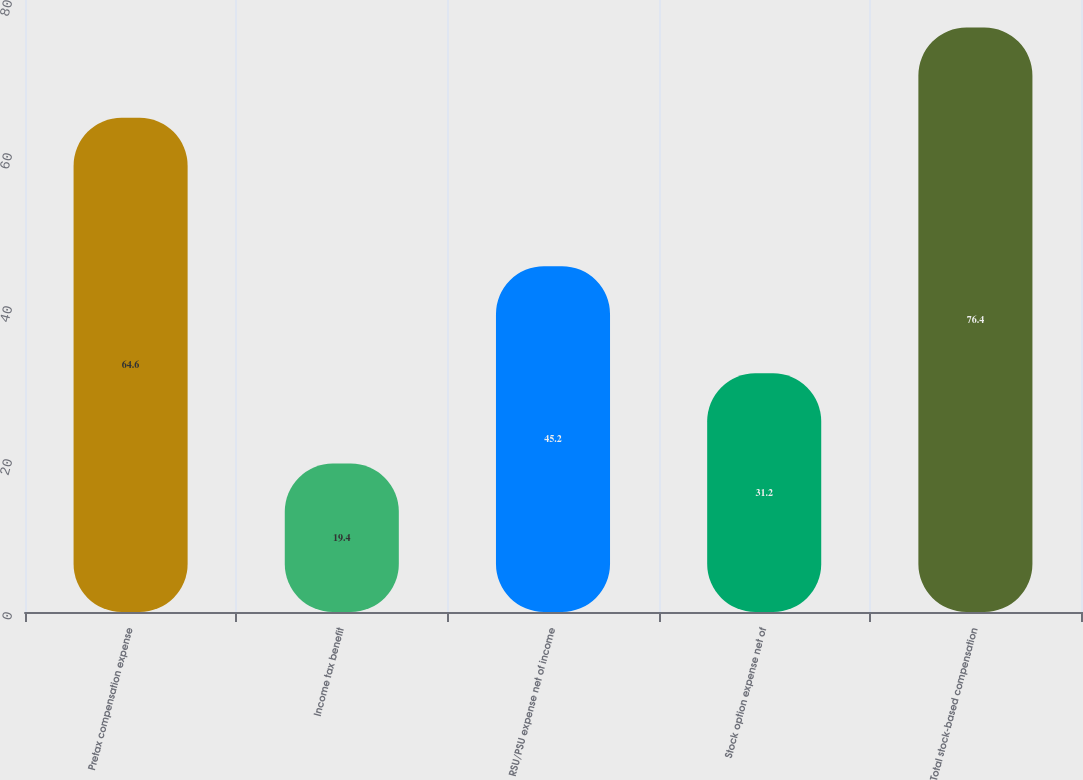Convert chart. <chart><loc_0><loc_0><loc_500><loc_500><bar_chart><fcel>Pretax compensation expense<fcel>Income tax benefit<fcel>RSU/PSU expense net of income<fcel>Stock option expense net of<fcel>Total stock-based compensation<nl><fcel>64.6<fcel>19.4<fcel>45.2<fcel>31.2<fcel>76.4<nl></chart> 